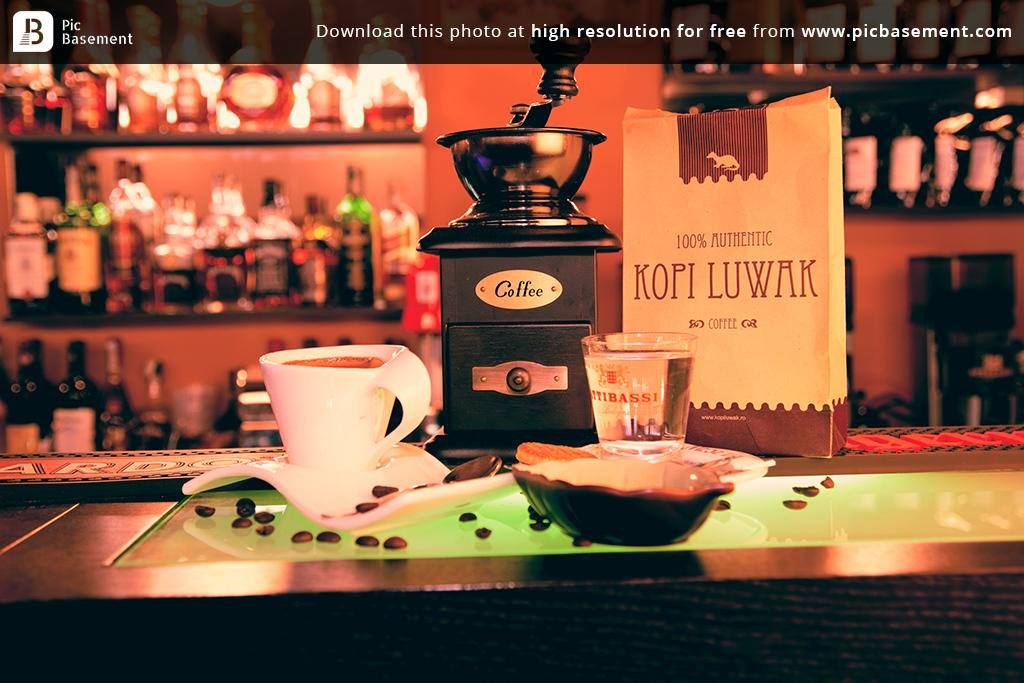Provide a one-sentence caption for the provided image. A bag of Kopi Luwak coffee on a table with a cup and beans. 